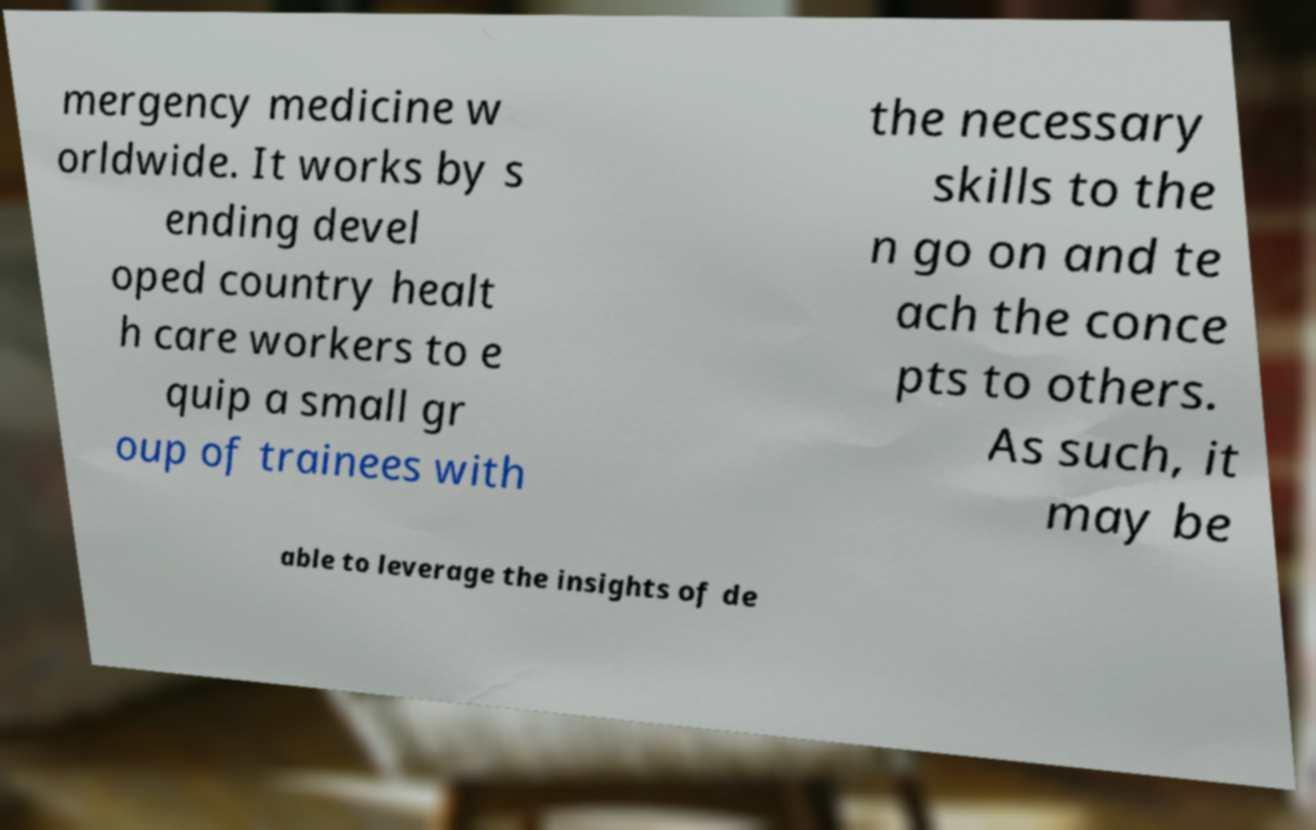What messages or text are displayed in this image? I need them in a readable, typed format. mergency medicine w orldwide. It works by s ending devel oped country healt h care workers to e quip a small gr oup of trainees with the necessary skills to the n go on and te ach the conce pts to others. As such, it may be able to leverage the insights of de 